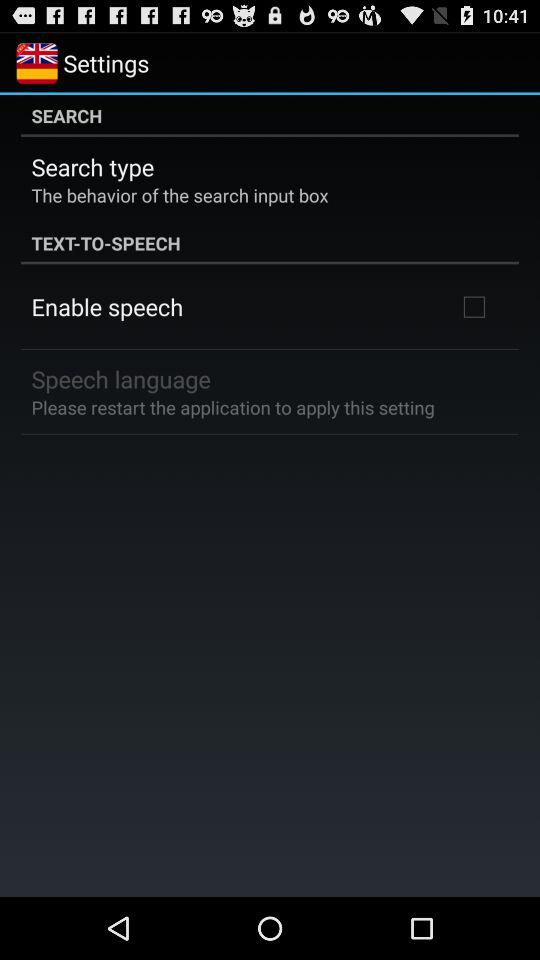What is the status of "Enable speech"? The status is off. 